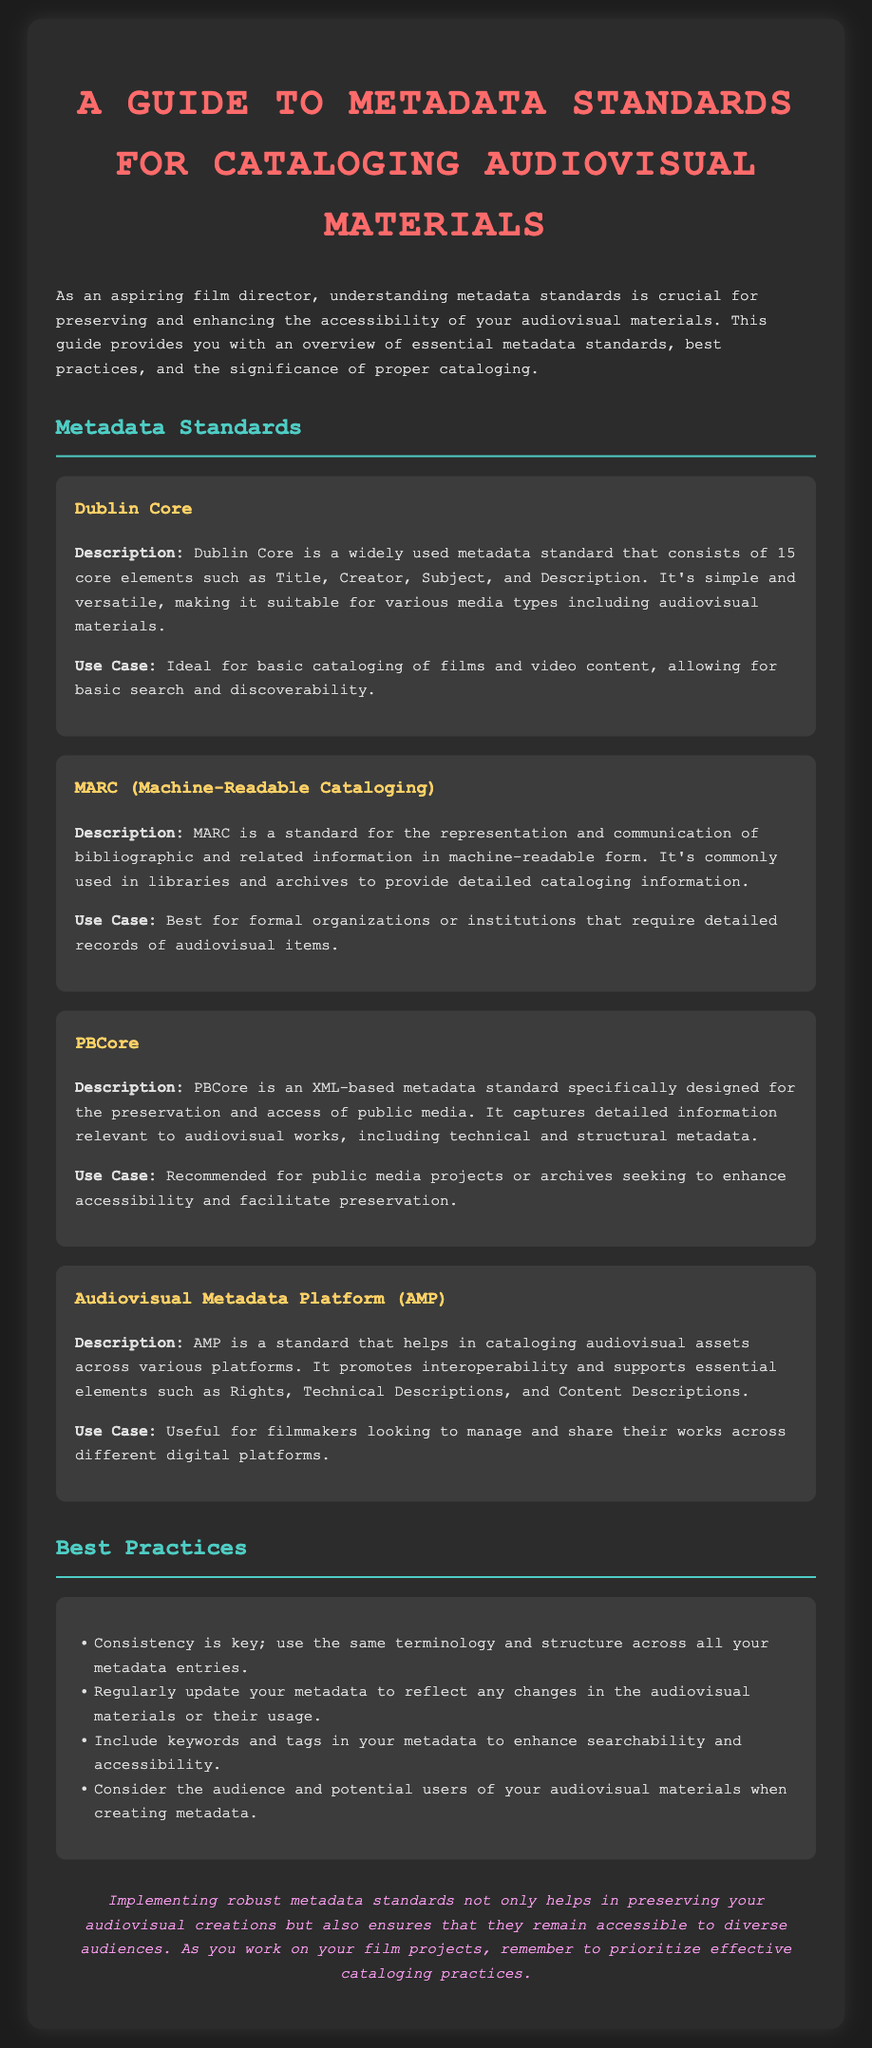what is the title of the document? The title of the document is prominently displayed at the top of the rendered document.
Answer: A Guide to Metadata Standards for Cataloging Audiovisual Materials how many core elements does Dublin Core consist of? The document states that Dublin Core consists of 15 core elements.
Answer: 15 which metadata standard is specifically designed for public media? The document identifies PBCore as the metadata standard designed for public media.
Answer: PBCore what is one of the best practices mentioned for metadata entries? The best practices section lists various strategies for effective metadata; one is highlighted within the paragraph.
Answer: Consistency is key what is the primary audience for the guide? The introductory paragraph specifies the intended readers of the guide, establishing the focus.
Answer: aspiring film director which metadata standard is described as useful for filmmakers managing their works? The document outlines the usefulness of AMP for filmmakers in the specific context provided.
Answer: Audiovisual Metadata Platform (AMP) what color is used for the headings in the document? The document describes the color scheme used for headings, focusing on textual elements.
Answer: #4ecdc4 what should be included in metadata to enhance searchability? The best practices section suggests various methods to improve the efficacy of metadata entries.
Answer: keywords and tags 